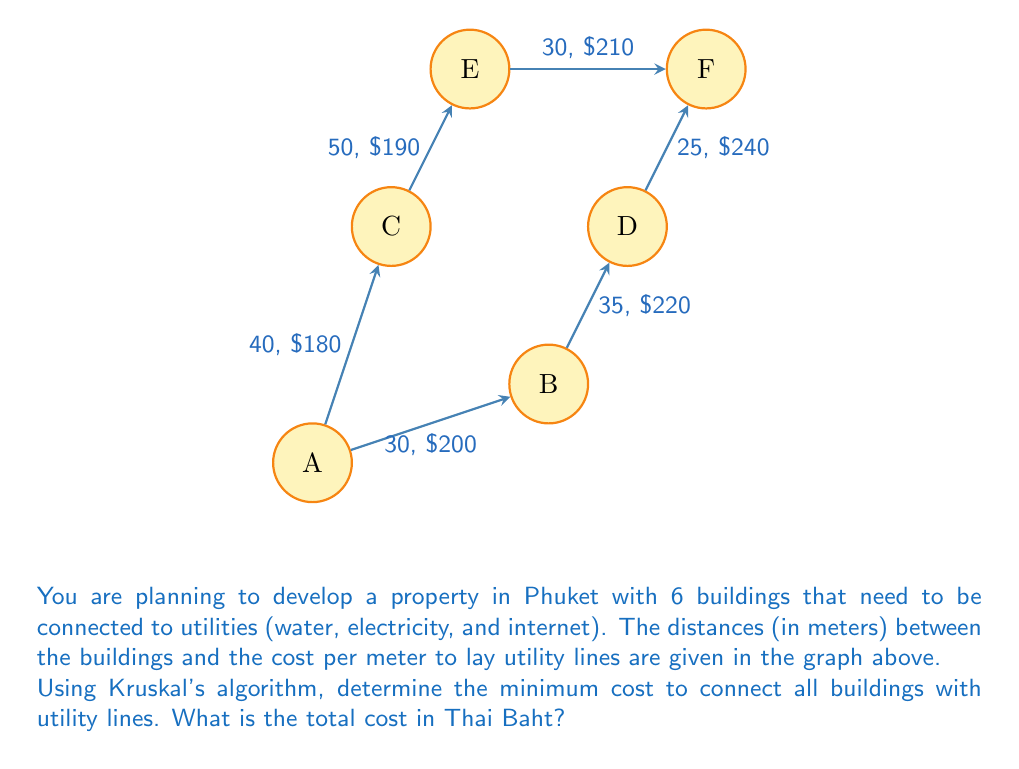Can you answer this question? To solve this problem, we'll use Kruskal's algorithm to find the minimum spanning tree of the graph. This will give us the most efficient layout for the utilities. Here's the step-by-step process:

1) First, sort all edges by weight (cost per meter * distance):
   AB: 30 * 200 = 6000 THB
   AC: 40 * 180 = 7200 THB
   BD: 35 * 220 = 7700 THB
   CE: 50 * 190 = 9500 THB
   DF: 25 * 240 = 6000 THB
   EF: 30 * 210 = 6300 THB

   Sorted: AB (6000), DF (6000), EF (6300), AC (7200), BD (7700), CE (9500)

2) Now, apply Kruskal's algorithm:
   - Add AB (6000) to the tree
   - Add DF (6000) to the tree
   - Add EF (6300) to the tree
   - Skip AC (7200) as it would create a cycle
   - Add BD (7700) to the tree
   - Add CE (9500) to the tree

3) The minimum spanning tree is now complete, connecting all vertices.

4) Calculate the total cost:
   Total = 6000 + 6000 + 6300 + 7700 + 9500 = 35500 THB

Therefore, the minimum cost to connect all buildings with utility lines is 35,500 Thai Baht.
Answer: 35,500 THB 